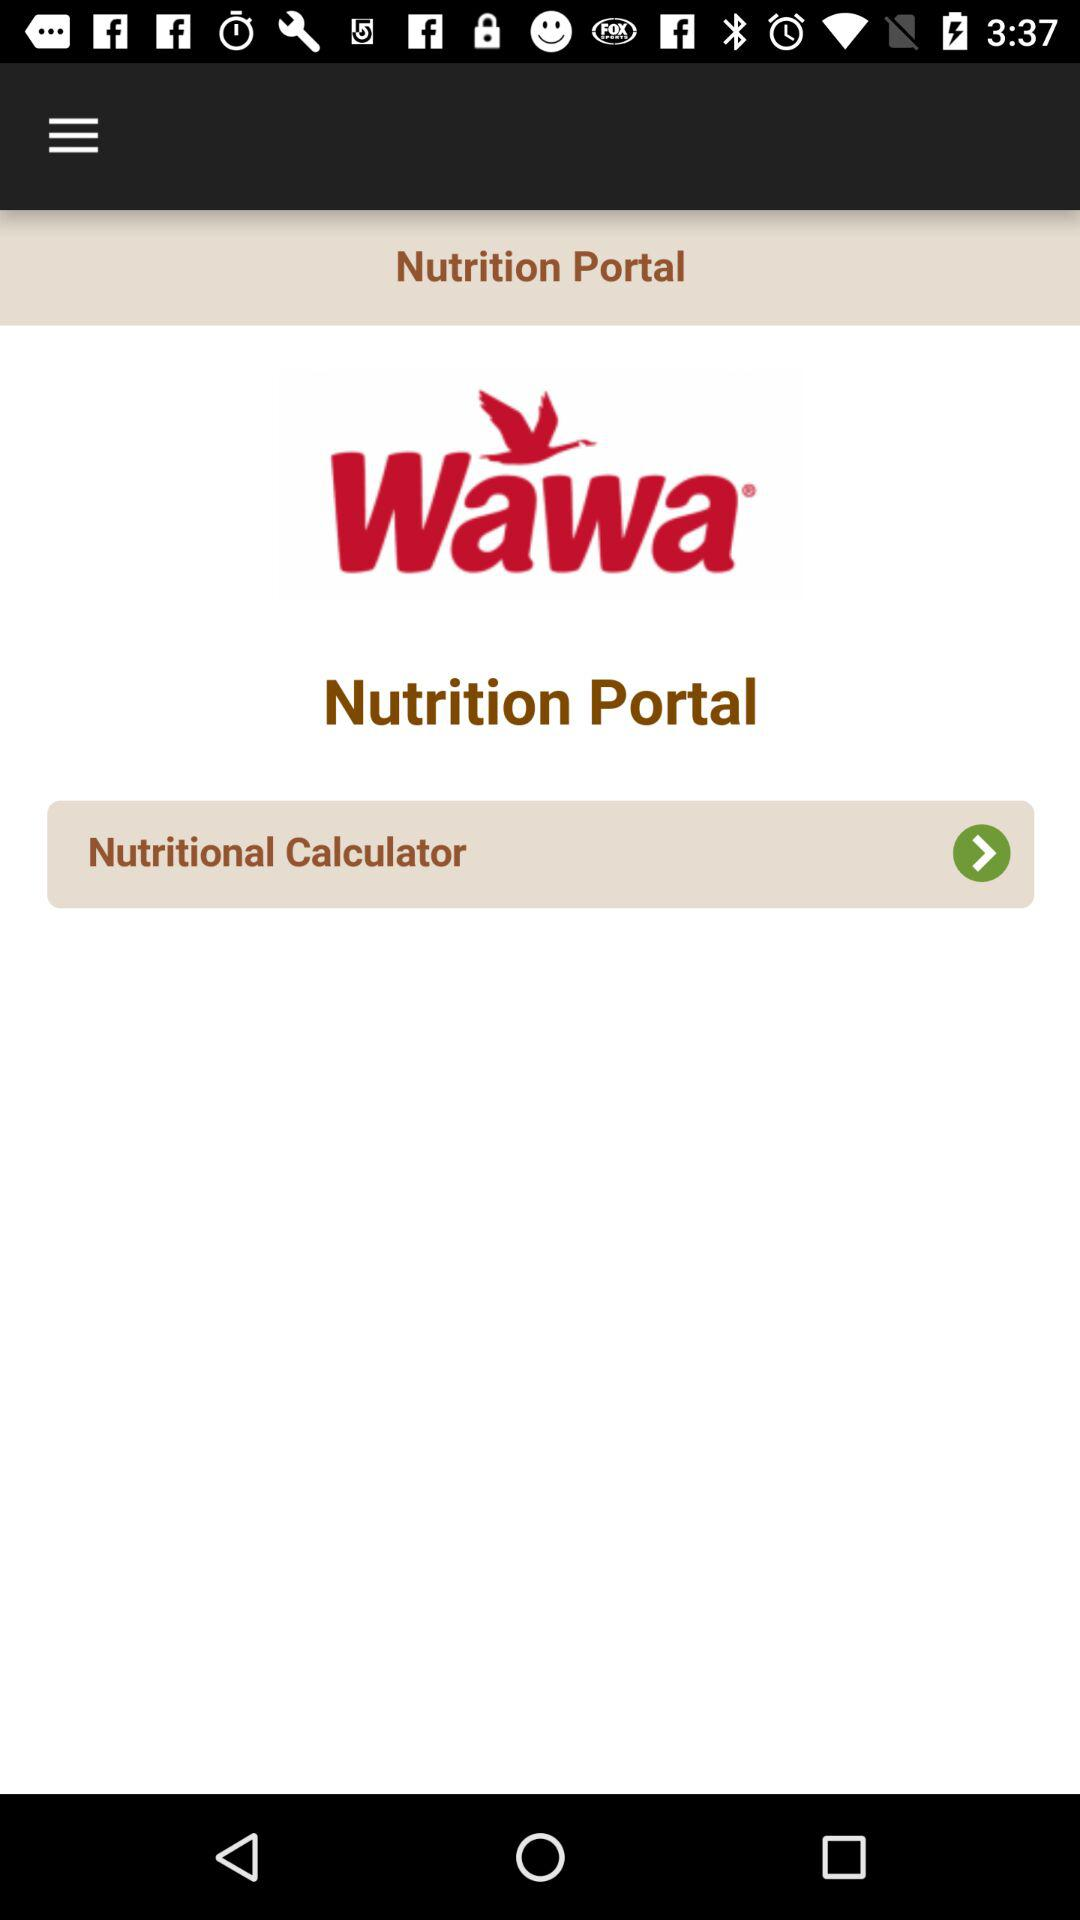What is the application name? The application name is "Wawa". 